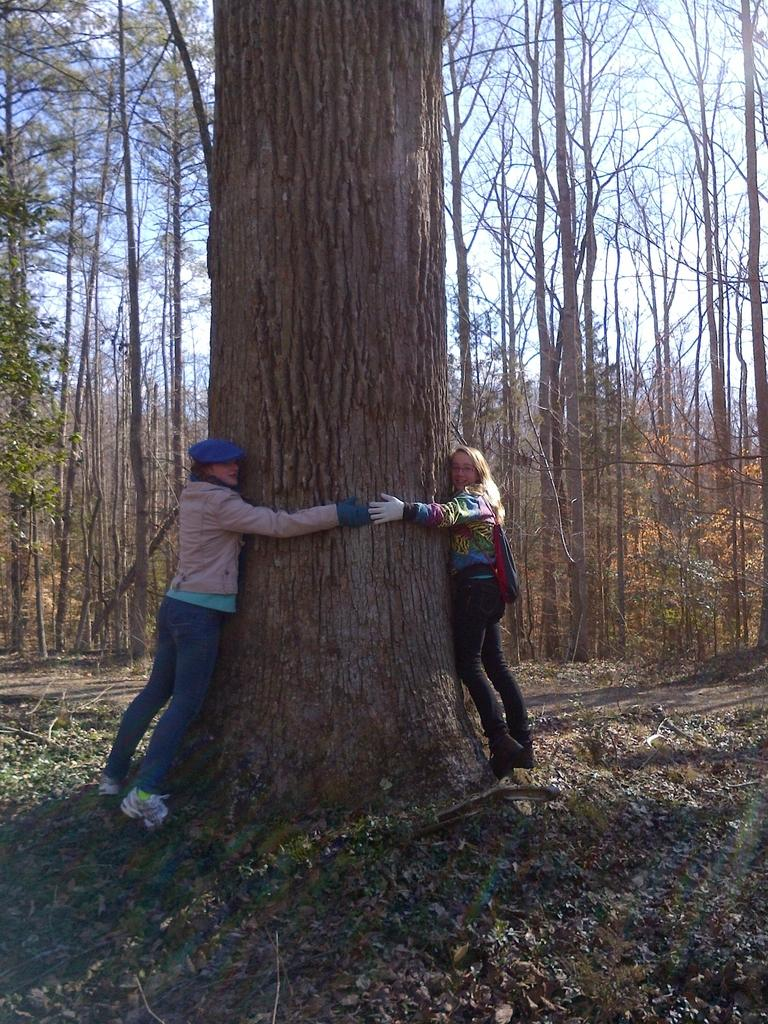How many people are in the image? There are two people in the image. What are the people doing in the image? The people are standing and hugging a tree trunk. What type of vegetation is present in the image? There are trees with branches and leaves in the image. What is on the ground in the image? Dried leaves are lying on the ground in the image. What type of corn can be seen in the image? There is no corn present in the image. 